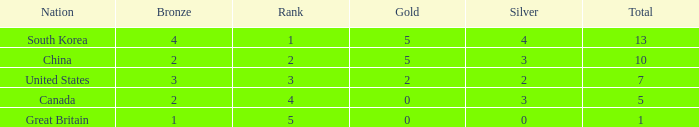What is the lowest Rank, when Nation is Great Britain, and when Bronze is less than 1? None. 